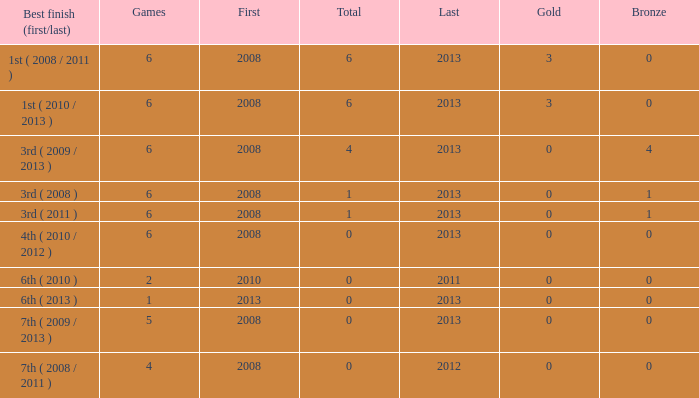How many games are associated with over 0 golds and a first year before 2008? None. 